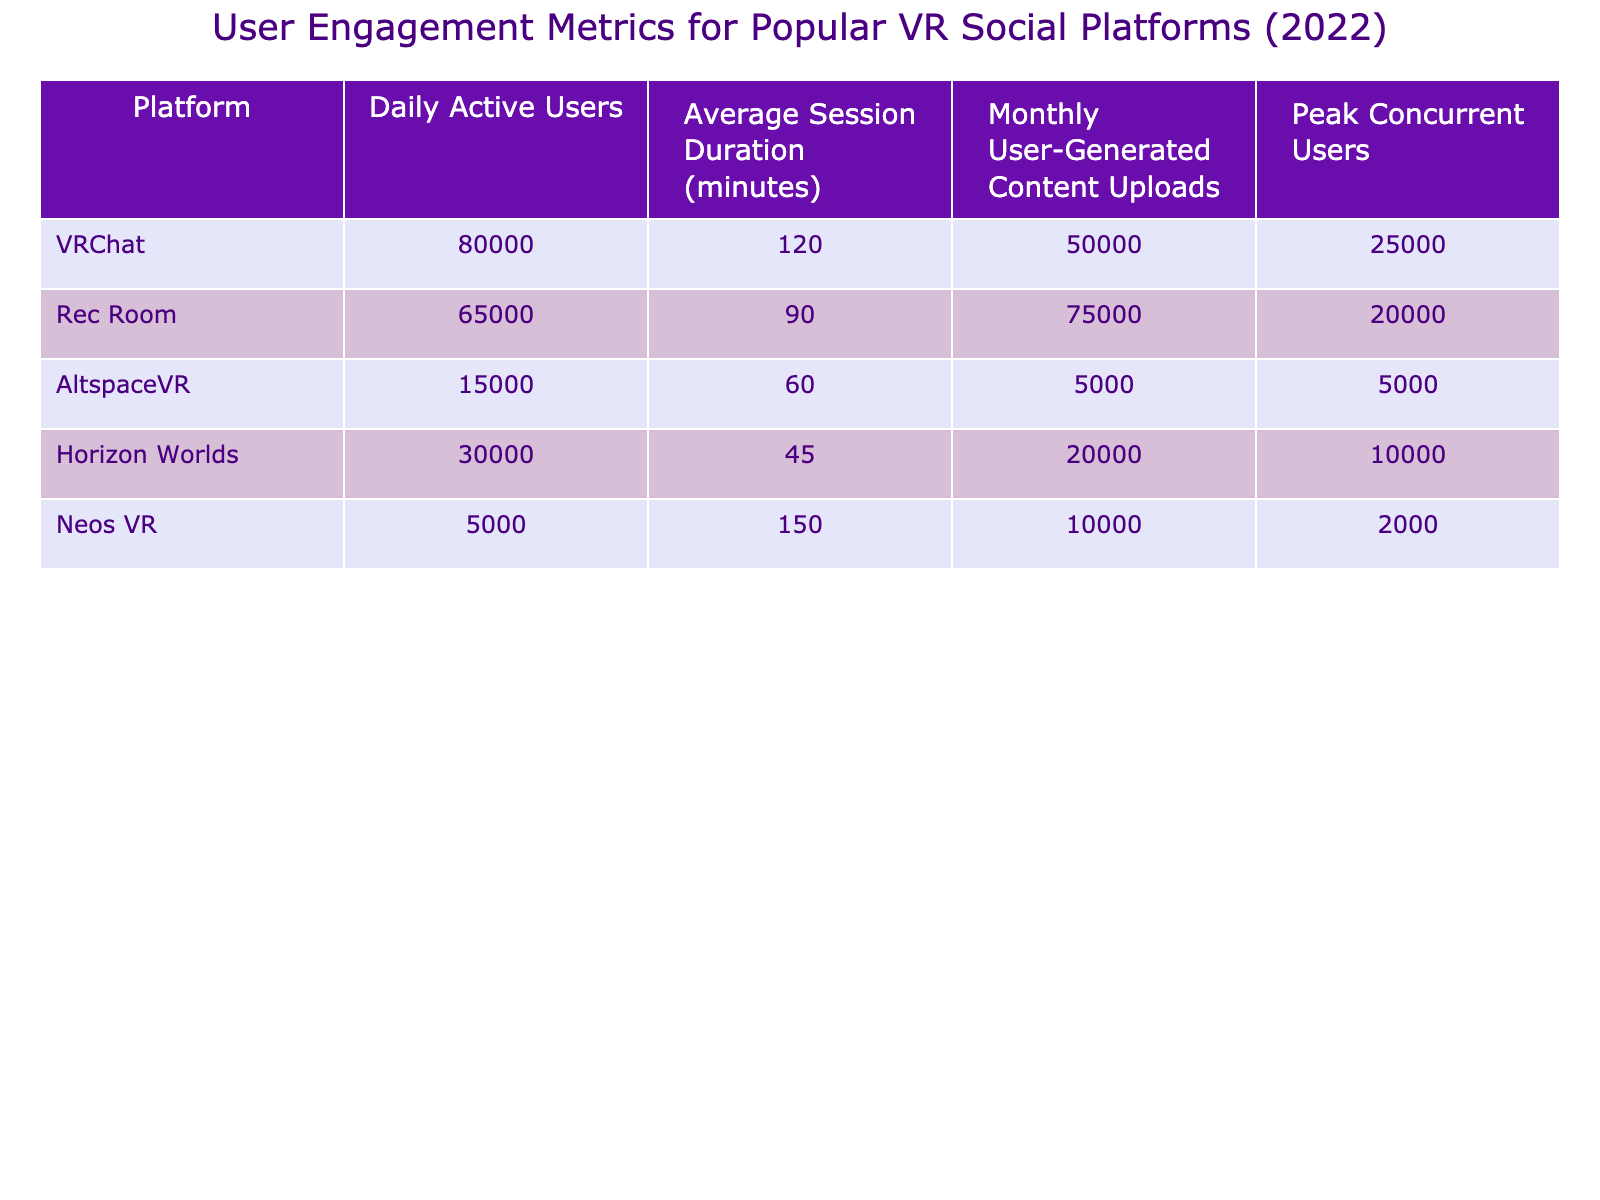What is the daily active user count for VRChat? The daily active user count for VRChat is listed directly in the table under the relevant metric. It states that there are 80,000 daily active users.
Answer: 80,000 What is the average session duration for Rec Room? The average session duration for Rec Room is provided in the table. It indicates that the average session duration is 90 minutes.
Answer: 90 minutes Which platform has the highest peak concurrent users? To determine this, I will look across all platforms. VRChat has the highest peak concurrent users with a count of 25,000.
Answer: VRChat What is the total number of monthly user-generated content uploads for VRChat and Rec Room combined? I will sum the monthly uploads for both platforms: 50,000 (VRChat) + 75,000 (Rec Room) = 125,000.
Answer: 125,000 Is there any platform with more than 70,000 daily active users? By reviewing the daily active user counts listed, only VRChat has more than 70,000 daily active users (80,000). Yes, VRChat exceeds this threshold.
Answer: Yes Which platform has the longest average session duration, and what is that duration? The average session duration for each platform needs to be compared. VRChat has the longest session duration at 120 minutes.
Answer: VRChat, 120 minutes What is the average number of monthly user-generated content uploads across all platforms? To find the average, I will sum the monthly uploads: 50,000 (VRChat) + 75,000 (Rec Room) + 5,000 (AltspaceVR) + 20,000 (Horizon Worlds) + 10,000 (Neos VR) = 160,000, and then divide by the number of platforms (5): 160,000 / 5 = 32,000.
Answer: 32,000 What is the difference in peak concurrent users between VRChat and AltspaceVR? I will subtract the peak concurrent users of AltspaceVR (5,000) from those of VRChat (25,000): 25,000 - 5,000 = 20,000.
Answer: 20,000 Which platform has the most monthly user-generated content uploads? By comparing the monthly uploads, Rec Room has the most with 75,000 uploads.
Answer: Rec Room Is Neos VR the platform with the least number of daily active users? Yes, by checking the daily active user counts, Neos VR only has 5,000 users, which is indeed the lowest among all platforms.
Answer: Yes 